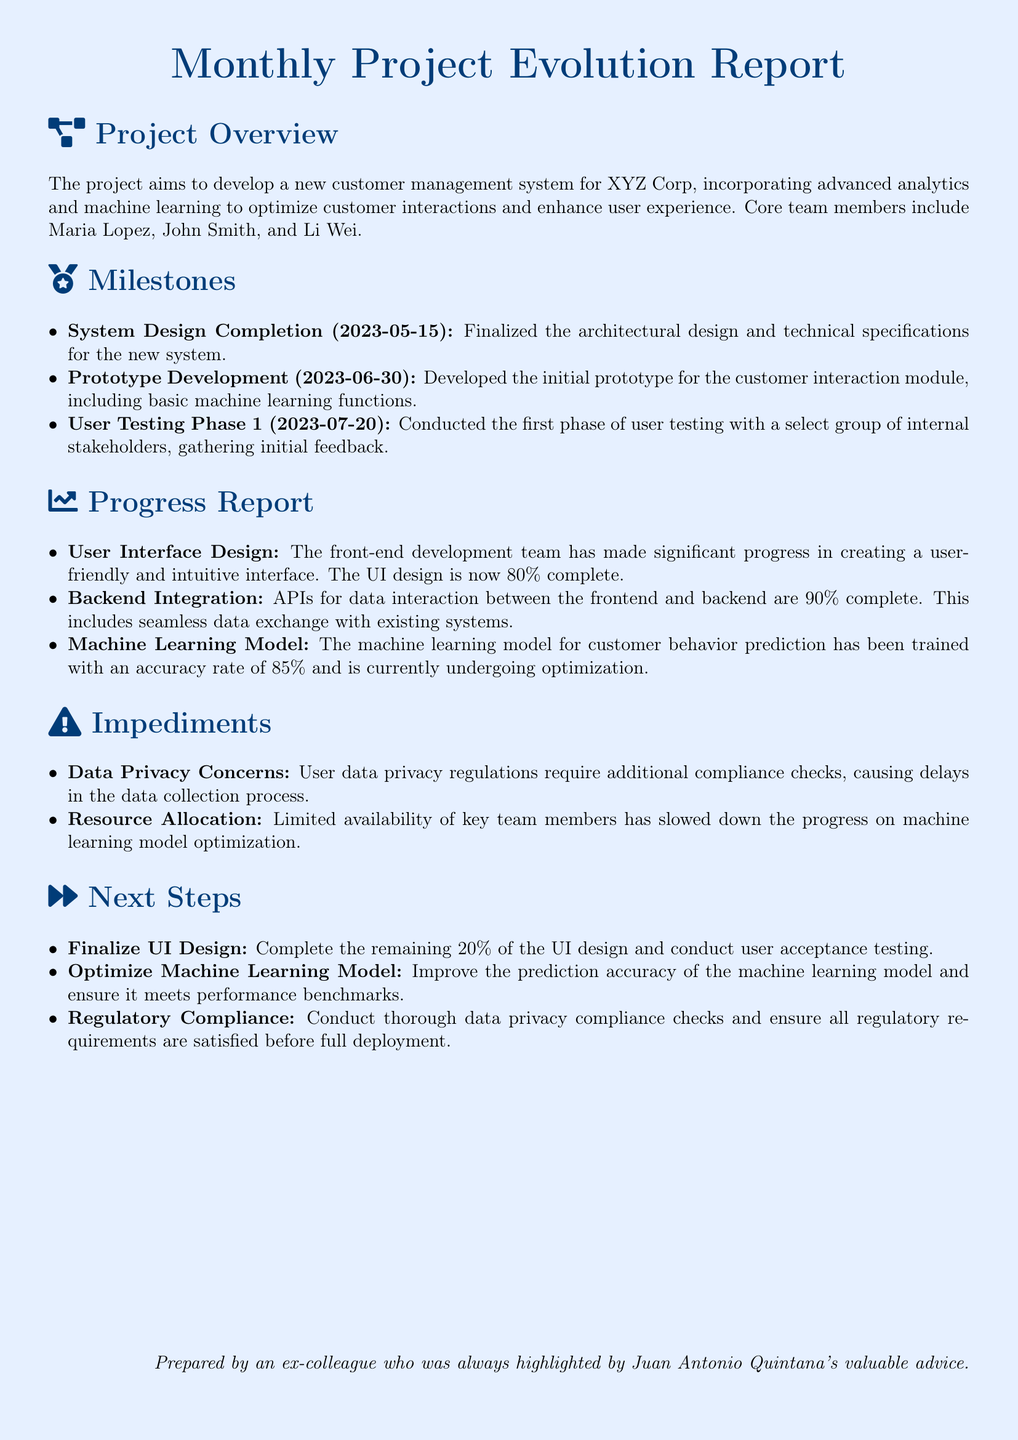What is the completion date for the System Design? The completion date for the System Design milestone is stated in the document as May 15, 2023.
Answer: May 15, 2023 Who are the core team members mentioned? The document lists Maria Lopez, John Smith, and Li Wei as the core team members of the project.
Answer: Maria Lopez, John Smith, Li Wei What percentage of the UI design is complete? The document indicates that 80% of the UI design is complete as part of the progress report.
Answer: 80% What is the current accuracy rate of the machine learning model? The document states that the machine learning model has an accuracy rate of 85%.
Answer: 85% What impediment relates to privacy regulations? The document specifically mentions "Data Privacy Concerns" as an impediment related to user data privacy regulations.
Answer: Data Privacy Concerns What is the next step for the machine learning model? The next step outlined for the machine learning model is to improve its prediction accuracy and meet performance benchmarks.
Answer: Optimize Machine Learning Model When was the User Testing Phase 1 conducted? The document indicates that User Testing Phase 1 was conducted on July 20, 2023.
Answer: July 20, 2023 What milestone was completed before Prototype Development? The document states that the milestone "System Design Completion" was completed before "Prototype Development."
Answer: System Design Completion What regulatory compliance check is planned as a next step? The document emphasizes that "Regulatory Compliance" checks are planned as a next step before full deployment.
Answer: Regulatory Compliance 